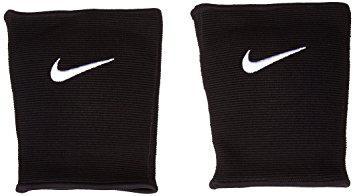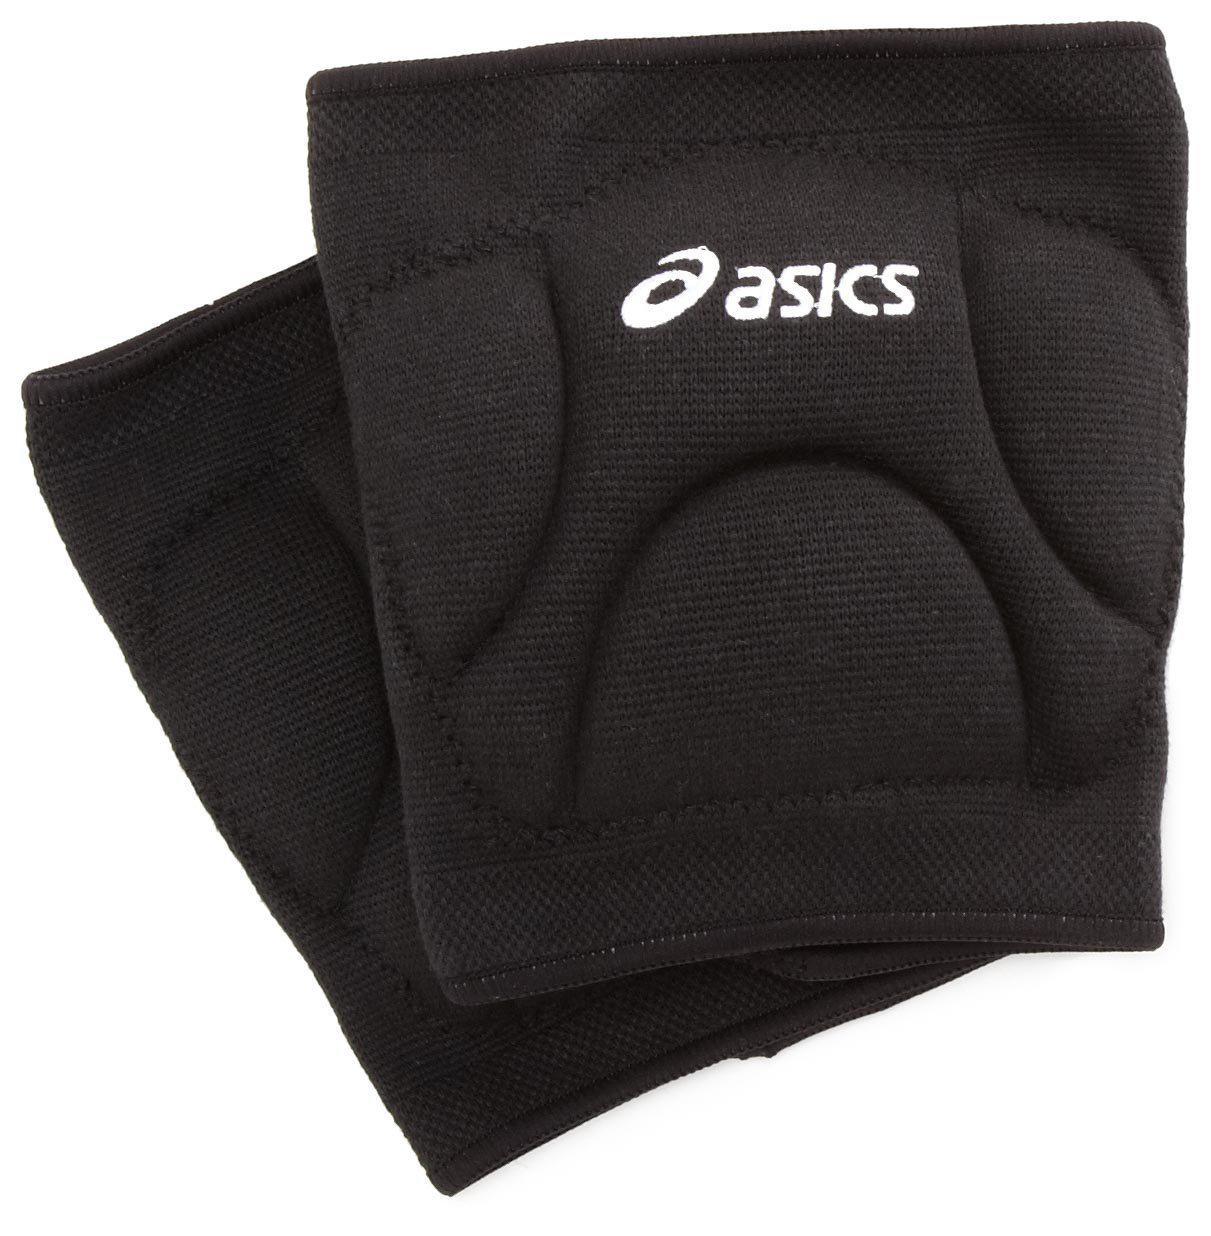The first image is the image on the left, the second image is the image on the right. Evaluate the accuracy of this statement regarding the images: "The right image contains exactly two black knee pads.". Is it true? Answer yes or no. Yes. The first image is the image on the left, the second image is the image on the right. For the images shown, is this caption "A white kneepad is next to a black kneepad in at least one of the images." true? Answer yes or no. No. The first image is the image on the left, the second image is the image on the right. Examine the images to the left and right. Is the description "There is one white and one black knee brace in the left image." accurate? Answer yes or no. No. The first image is the image on the left, the second image is the image on the right. Examine the images to the left and right. Is the description "Each image includes a black knee pad and a white knee pad." accurate? Answer yes or no. No. 